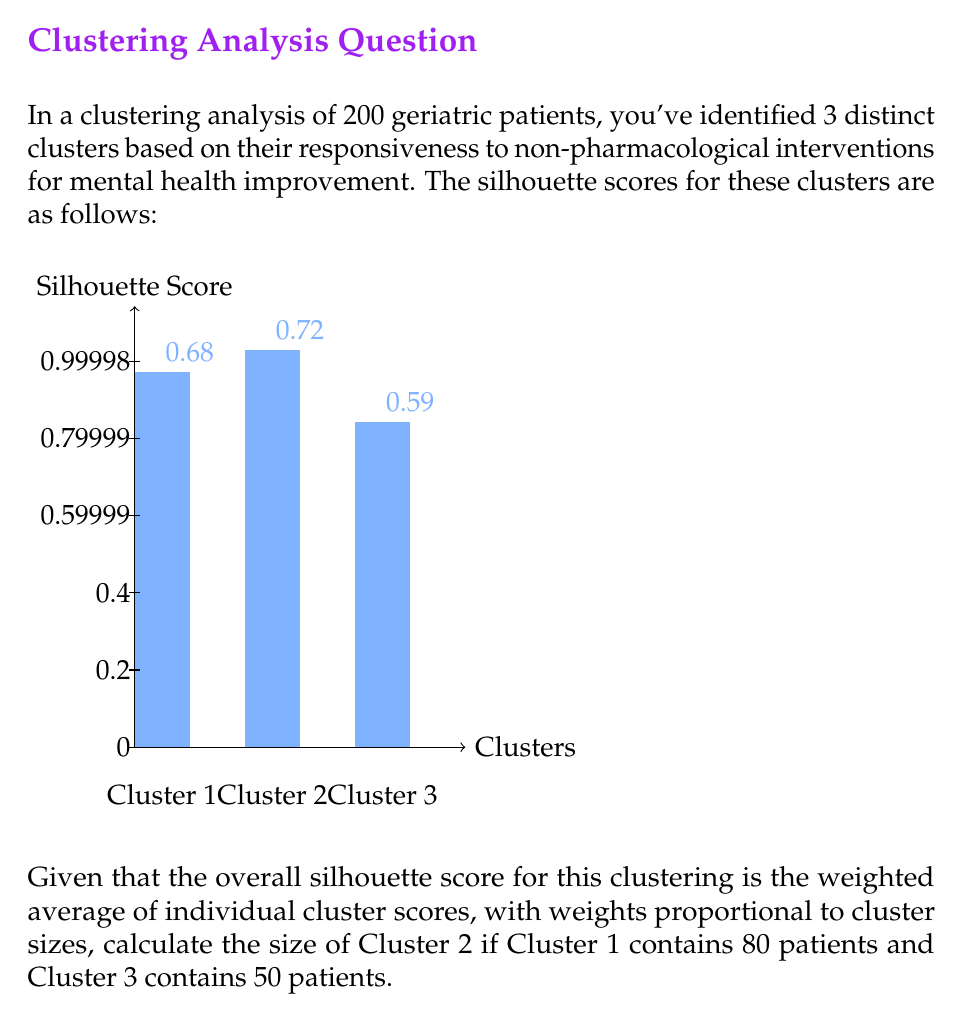Can you answer this question? Let's approach this step-by-step:

1) First, recall that the silhouette score ranges from -1 to 1, where a higher value indicates better-defined clusters. The overall silhouette score is a weighted average of individual cluster scores.

2) Let $x$ be the number of patients in Cluster 2. We know:
   - Cluster 1 has 80 patients
   - Cluster 2 has $x$ patients
   - Cluster 3 has 50 patients
   - Total patients = 200

3) The weighted average formula for the overall silhouette score ($S$) is:

   $$S = \frac{80 \cdot 0.68 + x \cdot 0.72 + 50 \cdot 0.59}{200}$$

4) We don't know the overall silhouette score, but we can use the fact that the total number of patients is 200:

   $$80 + x + 50 = 200$$
   $$x = 70$$

5) Let's verify this result by calculating the overall silhouette score:

   $$S = \frac{80 \cdot 0.68 + 70 \cdot 0.72 + 50 \cdot 0.59}{200}$$
   $$S = \frac{54.4 + 50.4 + 29.5}{200} = \frac{134.3}{200} = 0.6715$$

6) This overall score of 0.6715 is a reasonable weighted average of the individual cluster scores (0.68, 0.72, 0.59), confirming our calculation.
Answer: 70 patients 